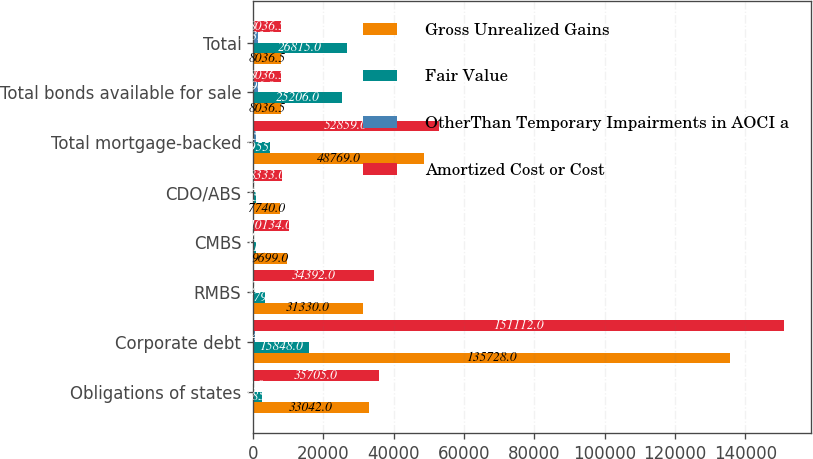Convert chart. <chart><loc_0><loc_0><loc_500><loc_500><stacked_bar_chart><ecel><fcel>Obligations of states<fcel>Corporate debt<fcel>RMBS<fcel>CMBS<fcel>CDO/ABS<fcel>Total mortgage-backed<fcel>Total bonds available for sale<fcel>Total<nl><fcel>Gross Unrealized Gains<fcel>33042<fcel>135728<fcel>31330<fcel>9699<fcel>7740<fcel>48769<fcel>8036.5<fcel>8036.5<nl><fcel>Fair Value<fcel>2685<fcel>15848<fcel>3379<fcel>811<fcel>765<fcel>4955<fcel>25206<fcel>26815<nl><fcel>OtherThan Temporary Impairments in AOCI a<fcel>22<fcel>464<fcel>317<fcel>376<fcel>172<fcel>865<fcel>1396<fcel>1433<nl><fcel>Amortized Cost or Cost<fcel>35705<fcel>151112<fcel>34392<fcel>10134<fcel>8333<fcel>52859<fcel>8036.5<fcel>8036.5<nl></chart> 